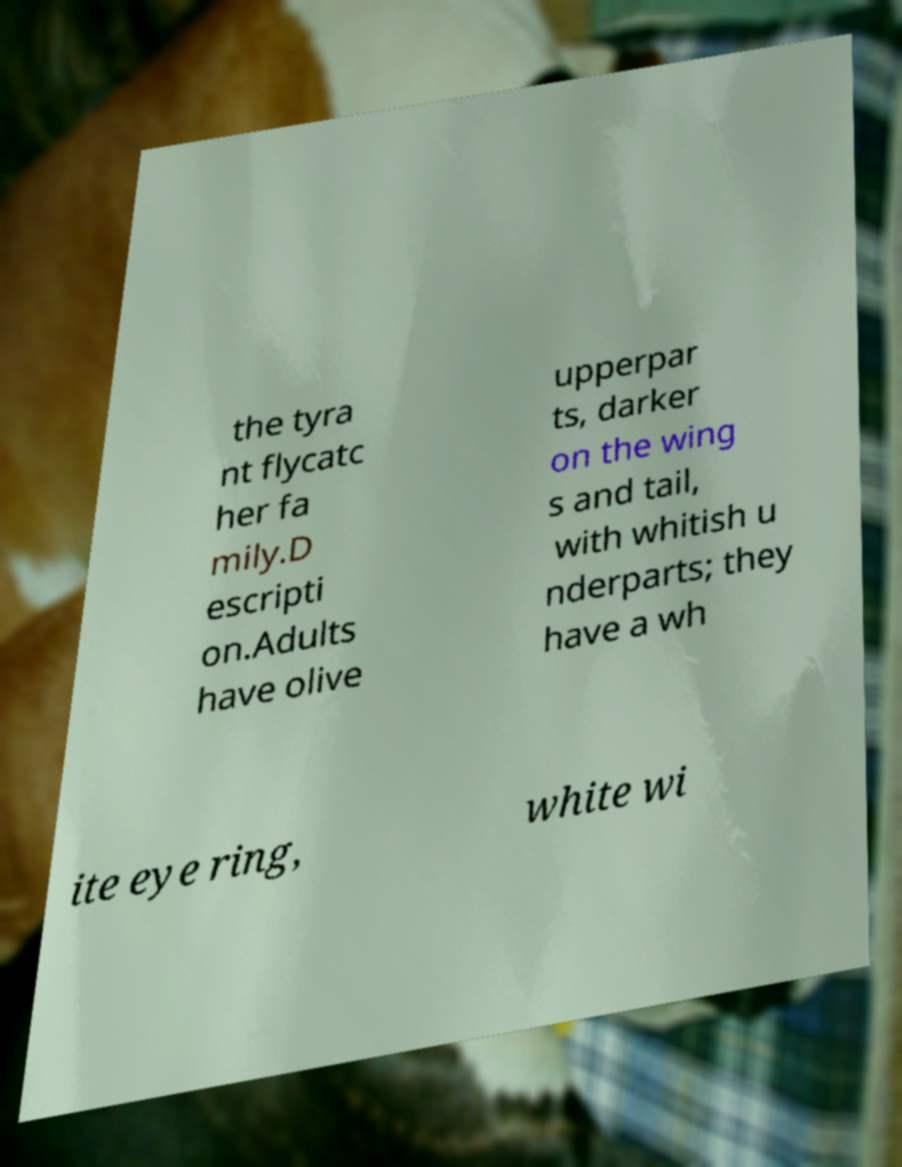Can you read and provide the text displayed in the image?This photo seems to have some interesting text. Can you extract and type it out for me? the tyra nt flycatc her fa mily.D escripti on.Adults have olive upperpar ts, darker on the wing s and tail, with whitish u nderparts; they have a wh ite eye ring, white wi 